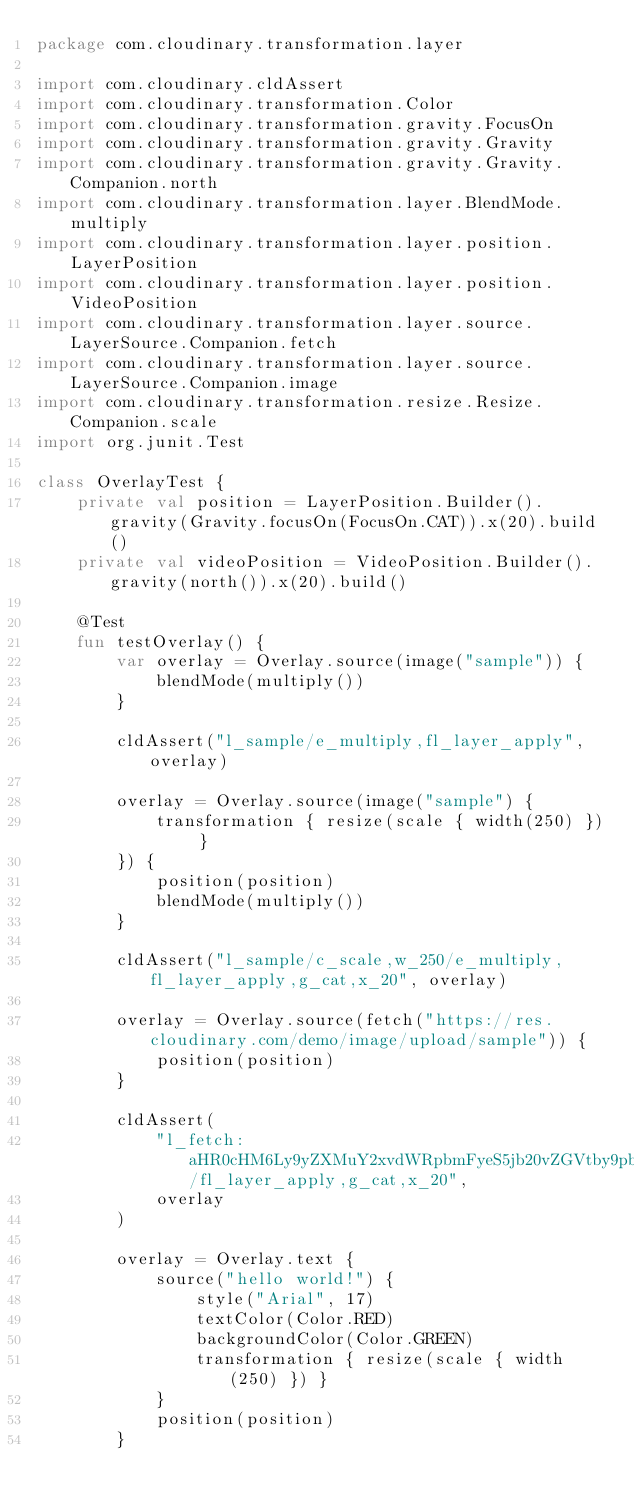Convert code to text. <code><loc_0><loc_0><loc_500><loc_500><_Kotlin_>package com.cloudinary.transformation.layer

import com.cloudinary.cldAssert
import com.cloudinary.transformation.Color
import com.cloudinary.transformation.gravity.FocusOn
import com.cloudinary.transformation.gravity.Gravity
import com.cloudinary.transformation.gravity.Gravity.Companion.north
import com.cloudinary.transformation.layer.BlendMode.multiply
import com.cloudinary.transformation.layer.position.LayerPosition
import com.cloudinary.transformation.layer.position.VideoPosition
import com.cloudinary.transformation.layer.source.LayerSource.Companion.fetch
import com.cloudinary.transformation.layer.source.LayerSource.Companion.image
import com.cloudinary.transformation.resize.Resize.Companion.scale
import org.junit.Test

class OverlayTest {
    private val position = LayerPosition.Builder().gravity(Gravity.focusOn(FocusOn.CAT)).x(20).build()
    private val videoPosition = VideoPosition.Builder().gravity(north()).x(20).build()

    @Test
    fun testOverlay() {
        var overlay = Overlay.source(image("sample")) {
            blendMode(multiply())
        }

        cldAssert("l_sample/e_multiply,fl_layer_apply", overlay)

        overlay = Overlay.source(image("sample") {
            transformation { resize(scale { width(250) }) }
        }) {
            position(position)
            blendMode(multiply())
        }

        cldAssert("l_sample/c_scale,w_250/e_multiply,fl_layer_apply,g_cat,x_20", overlay)

        overlay = Overlay.source(fetch("https://res.cloudinary.com/demo/image/upload/sample")) {
            position(position)
        }

        cldAssert(
            "l_fetch:aHR0cHM6Ly9yZXMuY2xvdWRpbmFyeS5jb20vZGVtby9pbWFnZS91cGxvYWQvc2FtcGxl/fl_layer_apply,g_cat,x_20",
            overlay
        )

        overlay = Overlay.text {
            source("hello world!") {
                style("Arial", 17)
                textColor(Color.RED)
                backgroundColor(Color.GREEN)
                transformation { resize(scale { width(250) }) }
            }
            position(position)
        }
</code> 